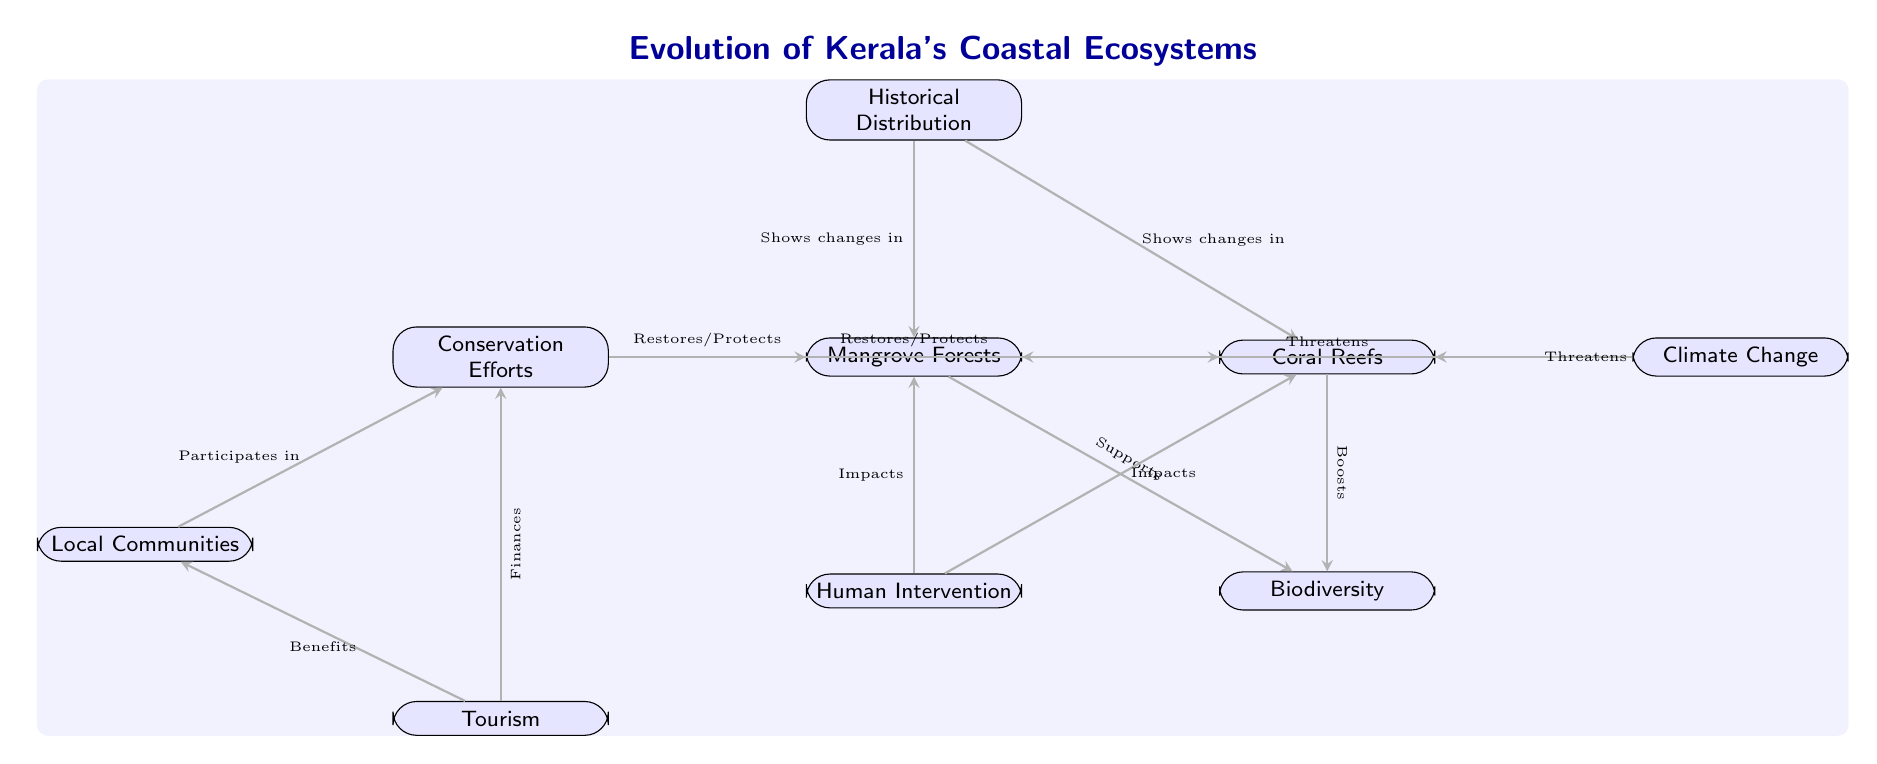What are the two main ecosystems depicted in the diagram? The diagram clearly shows two main ecosystems labeled: "Mangrove Forests" and "Coral Reefs." These are the central nodes representing the ecosystems analyzed in Kerala's coastal regions.
Answer: Mangrove Forests, Coral Reefs How many direct relationships are shown in the diagram? By counting the directed edges connecting the nodes, there are a total of eight relationships depicted in the diagram, connecting various factors to mangroves and coral reefs.
Answer: Eight Which node represents the impact of human activity? The node labeled "Human Intervention" directly indicates the influence of human activity on both mangrove forests and coral reefs, as represented by the arrows pointing toward these ecosystems.
Answer: Human Intervention What role do local communities play according to the diagram? The diagram shows that local communities "Participate in" conservation efforts, indicating their involvement in protecting the ecosystems depicted.
Answer: Participates in conservation What threatens both mangrove forests and coral reefs as shown in the diagram? The diagram indicates "Climate Change" with directed edges leading to both the mangrove and coral nodes, signifying that climate change poses a threat to both ecosystems.
Answer: Climate Change How do conservation efforts relate to mangrove forests? The diagram notes that "Conservation Efforts" "Restores/Protects" mangrove forests, showing a positive relationship where conservation actions help to maintain or improve the state of mangroves.
Answer: Restores/Protects What is the relationship between tourism and local communities in the diagram? The arrows in the diagram illustrate that tourism "Benefits" local communities and also "Finances" conservation, showing a dual relationship where tourism supports both the communities and conservation activities.
Answer: Benefits What is the significance of historical distribution according to the diagram? The "Historical Distribution" node points to both mangrove forests and coral reefs, suggesting that it highlights changes over time in these ecosystems, showing their evolution in response to environmental factors.
Answer: Shows changes in 